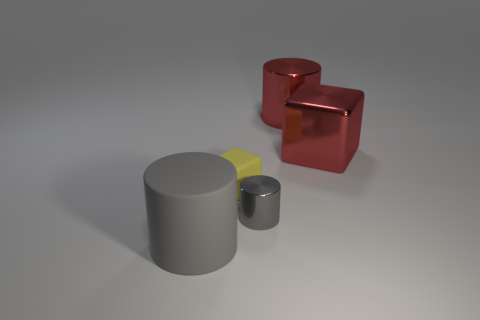There is a rubber thing that is in front of the small rubber object; is it the same color as the metallic thing that is left of the large metallic cylinder?
Provide a short and direct response. Yes. Is there any other thing that is the same material as the big gray object?
Offer a very short reply. Yes. The red metal object that is the same shape as the tiny yellow thing is what size?
Give a very brief answer. Large. Are there any tiny matte objects in front of the tiny shiny thing?
Your response must be concise. No. Are there the same number of metal cylinders behind the small metal thing and red metal objects?
Make the answer very short. No. Is there a large shiny object that is to the right of the cube that is right of the gray cylinder on the right side of the tiny yellow rubber block?
Your answer should be compact. No. What is the tiny gray cylinder made of?
Your answer should be compact. Metal. How many other objects are there of the same shape as the yellow thing?
Your answer should be very brief. 1. Does the big gray rubber thing have the same shape as the tiny gray metal thing?
Ensure brevity in your answer.  Yes. How many things are either large things that are on the right side of the matte block or big red metallic cylinders that are right of the big gray cylinder?
Provide a short and direct response. 2. 